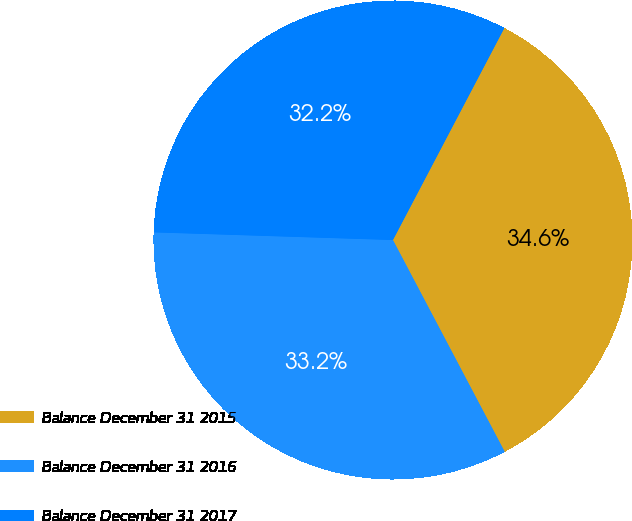Convert chart to OTSL. <chart><loc_0><loc_0><loc_500><loc_500><pie_chart><fcel>Balance December 31 2015<fcel>Balance December 31 2016<fcel>Balance December 31 2017<nl><fcel>34.57%<fcel>33.24%<fcel>32.19%<nl></chart> 